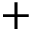Convert formula to latex. <formula><loc_0><loc_0><loc_500><loc_500>+</formula> 